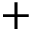Convert formula to latex. <formula><loc_0><loc_0><loc_500><loc_500>+</formula> 